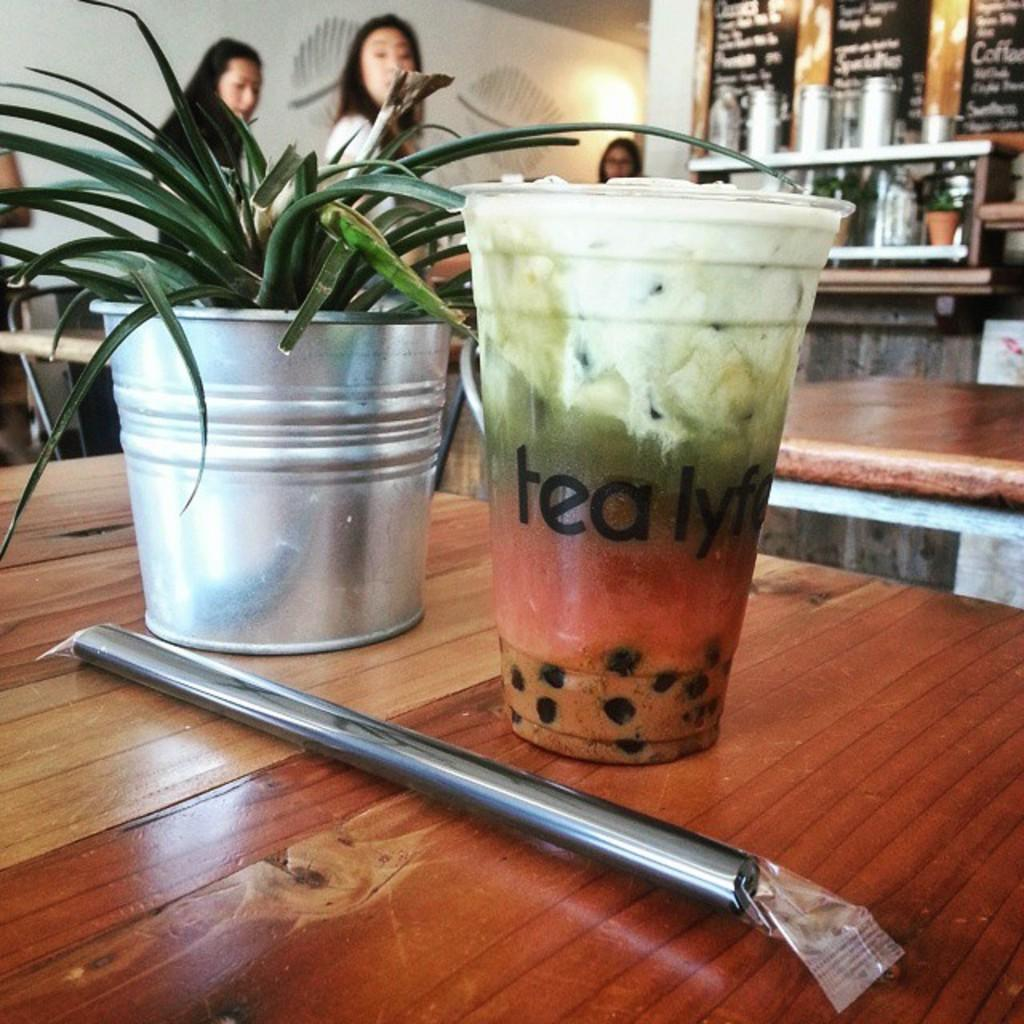What is the main object in the image? There is a plant pot in the image. What other object can be seen in the image? There is a glass in the image. What is the surface on which these objects are placed? The objects are placed on a wooden surface. Can you describe the background of the image? In the background, there are people, tables, bottles, lights, a wall, and other objects. What type of breakfast is being served on the table in the image? There is no table or breakfast visible in the image; it only shows a plant pot and a glass on a wooden surface. How does the wealth of the people in the image contribute to the presence of the plant pot and glass? The image does not provide any information about the wealth of the people or how it relates to the objects in the image. 